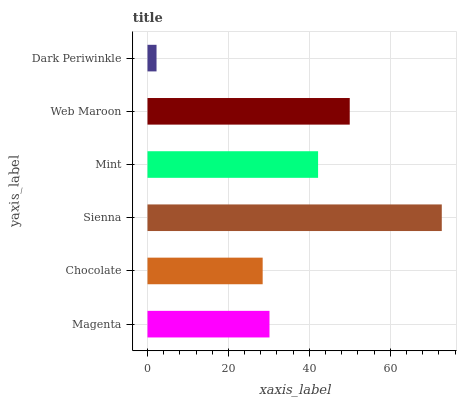Is Dark Periwinkle the minimum?
Answer yes or no. Yes. Is Sienna the maximum?
Answer yes or no. Yes. Is Chocolate the minimum?
Answer yes or no. No. Is Chocolate the maximum?
Answer yes or no. No. Is Magenta greater than Chocolate?
Answer yes or no. Yes. Is Chocolate less than Magenta?
Answer yes or no. Yes. Is Chocolate greater than Magenta?
Answer yes or no. No. Is Magenta less than Chocolate?
Answer yes or no. No. Is Mint the high median?
Answer yes or no. Yes. Is Magenta the low median?
Answer yes or no. Yes. Is Sienna the high median?
Answer yes or no. No. Is Mint the low median?
Answer yes or no. No. 